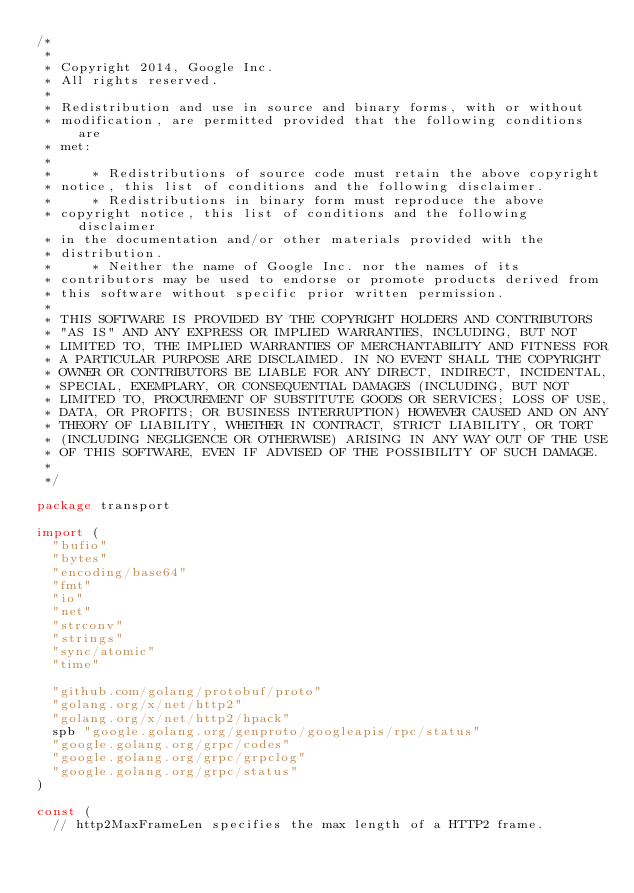Convert code to text. <code><loc_0><loc_0><loc_500><loc_500><_Go_>/*
 *
 * Copyright 2014, Google Inc.
 * All rights reserved.
 *
 * Redistribution and use in source and binary forms, with or without
 * modification, are permitted provided that the following conditions are
 * met:
 *
 *     * Redistributions of source code must retain the above copyright
 * notice, this list of conditions and the following disclaimer.
 *     * Redistributions in binary form must reproduce the above
 * copyright notice, this list of conditions and the following disclaimer
 * in the documentation and/or other materials provided with the
 * distribution.
 *     * Neither the name of Google Inc. nor the names of its
 * contributors may be used to endorse or promote products derived from
 * this software without specific prior written permission.
 *
 * THIS SOFTWARE IS PROVIDED BY THE COPYRIGHT HOLDERS AND CONTRIBUTORS
 * "AS IS" AND ANY EXPRESS OR IMPLIED WARRANTIES, INCLUDING, BUT NOT
 * LIMITED TO, THE IMPLIED WARRANTIES OF MERCHANTABILITY AND FITNESS FOR
 * A PARTICULAR PURPOSE ARE DISCLAIMED. IN NO EVENT SHALL THE COPYRIGHT
 * OWNER OR CONTRIBUTORS BE LIABLE FOR ANY DIRECT, INDIRECT, INCIDENTAL,
 * SPECIAL, EXEMPLARY, OR CONSEQUENTIAL DAMAGES (INCLUDING, BUT NOT
 * LIMITED TO, PROCUREMENT OF SUBSTITUTE GOODS OR SERVICES; LOSS OF USE,
 * DATA, OR PROFITS; OR BUSINESS INTERRUPTION) HOWEVER CAUSED AND ON ANY
 * THEORY OF LIABILITY, WHETHER IN CONTRACT, STRICT LIABILITY, OR TORT
 * (INCLUDING NEGLIGENCE OR OTHERWISE) ARISING IN ANY WAY OUT OF THE USE
 * OF THIS SOFTWARE, EVEN IF ADVISED OF THE POSSIBILITY OF SUCH DAMAGE.
 *
 */

package transport

import (
	"bufio"
	"bytes"
	"encoding/base64"
	"fmt"
	"io"
	"net"
	"strconv"
	"strings"
	"sync/atomic"
	"time"

	"github.com/golang/protobuf/proto"
	"golang.org/x/net/http2"
	"golang.org/x/net/http2/hpack"
	spb "google.golang.org/genproto/googleapis/rpc/status"
	"google.golang.org/grpc/codes"
	"google.golang.org/grpc/grpclog"
	"google.golang.org/grpc/status"
)

const (
	// http2MaxFrameLen specifies the max length of a HTTP2 frame.</code> 